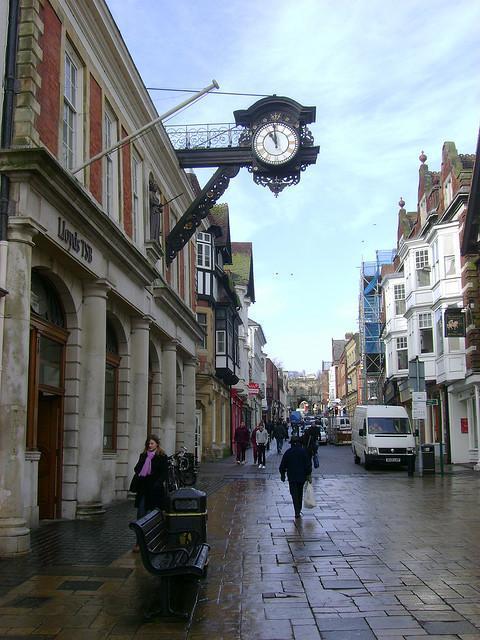How many stories are the white buildings on the right?
Give a very brief answer. 3. 